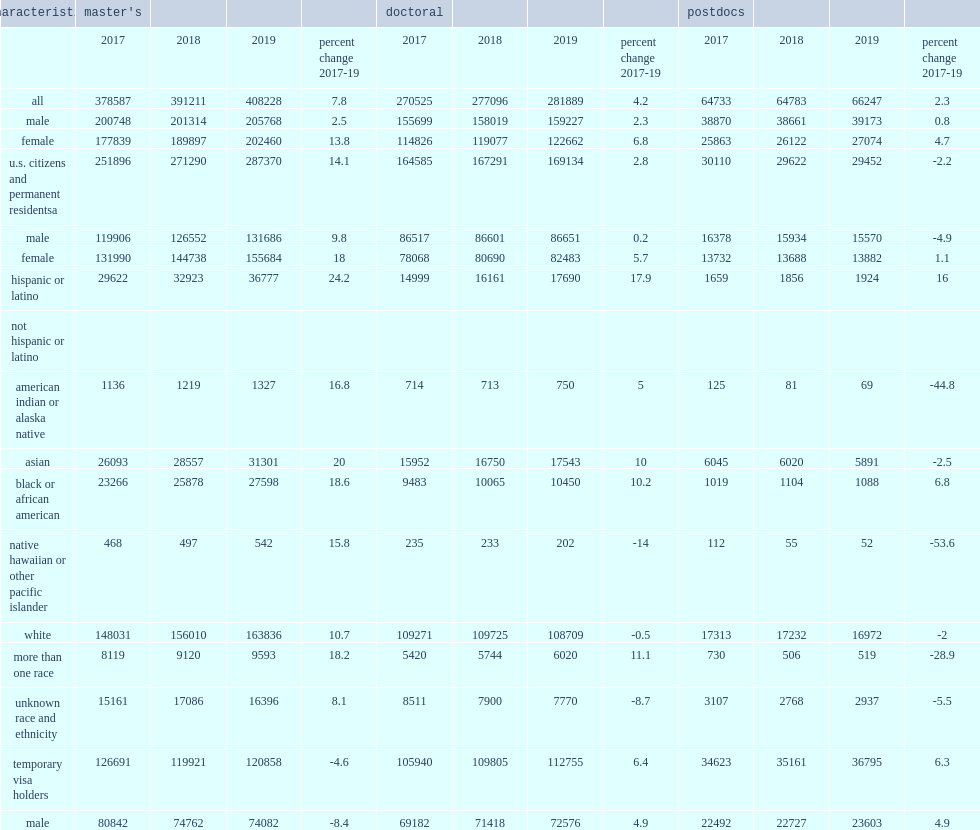How many percentage points of decreasing was the decline between 2017 and 2019 in the number and proportion of temporary visa holders among seh master's students driven in the number of men with temporary visas who enrolled in master's programs? 8.4. How many percentage points was the number of male doctoral students with temporary visas increased by? 4.9. 